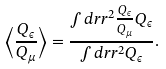<formula> <loc_0><loc_0><loc_500><loc_500>\left \langle \frac { Q _ { \epsilon } } { Q _ { \mu } } \right \rangle = \frac { \int d r r ^ { 2 } \frac { Q _ { \epsilon } } { Q _ { \mu } } Q _ { \epsilon } } { \int d r r ^ { 2 } Q _ { \epsilon } } .</formula> 